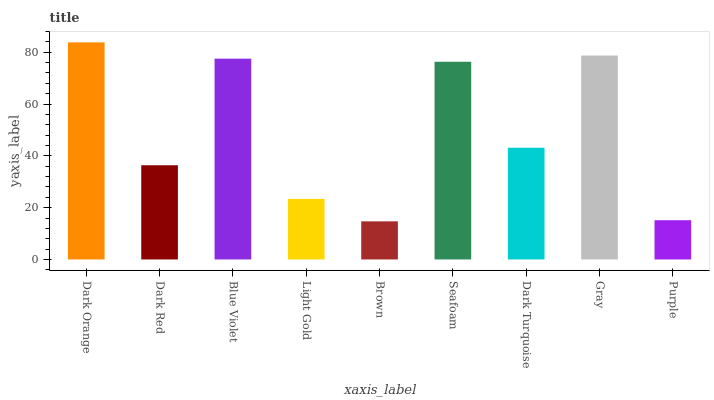Is Brown the minimum?
Answer yes or no. Yes. Is Dark Orange the maximum?
Answer yes or no. Yes. Is Dark Red the minimum?
Answer yes or no. No. Is Dark Red the maximum?
Answer yes or no. No. Is Dark Orange greater than Dark Red?
Answer yes or no. Yes. Is Dark Red less than Dark Orange?
Answer yes or no. Yes. Is Dark Red greater than Dark Orange?
Answer yes or no. No. Is Dark Orange less than Dark Red?
Answer yes or no. No. Is Dark Turquoise the high median?
Answer yes or no. Yes. Is Dark Turquoise the low median?
Answer yes or no. Yes. Is Brown the high median?
Answer yes or no. No. Is Dark Red the low median?
Answer yes or no. No. 